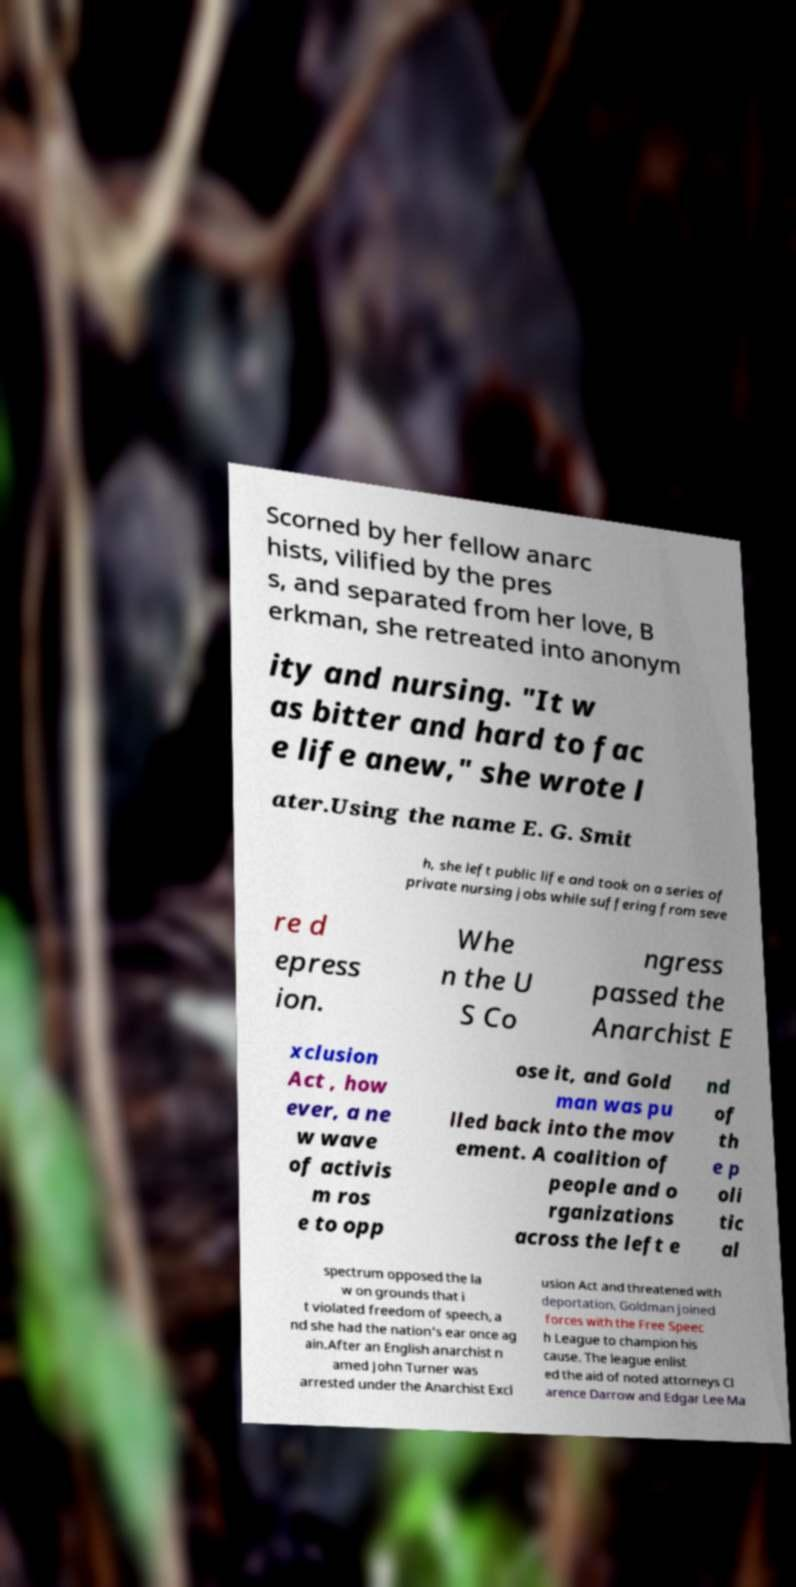For documentation purposes, I need the text within this image transcribed. Could you provide that? Scorned by her fellow anarc hists, vilified by the pres s, and separated from her love, B erkman, she retreated into anonym ity and nursing. "It w as bitter and hard to fac e life anew," she wrote l ater.Using the name E. G. Smit h, she left public life and took on a series of private nursing jobs while suffering from seve re d epress ion. Whe n the U S Co ngress passed the Anarchist E xclusion Act , how ever, a ne w wave of activis m ros e to opp ose it, and Gold man was pu lled back into the mov ement. A coalition of people and o rganizations across the left e nd of th e p oli tic al spectrum opposed the la w on grounds that i t violated freedom of speech, a nd she had the nation's ear once ag ain.After an English anarchist n amed John Turner was arrested under the Anarchist Excl usion Act and threatened with deportation, Goldman joined forces with the Free Speec h League to champion his cause. The league enlist ed the aid of noted attorneys Cl arence Darrow and Edgar Lee Ma 